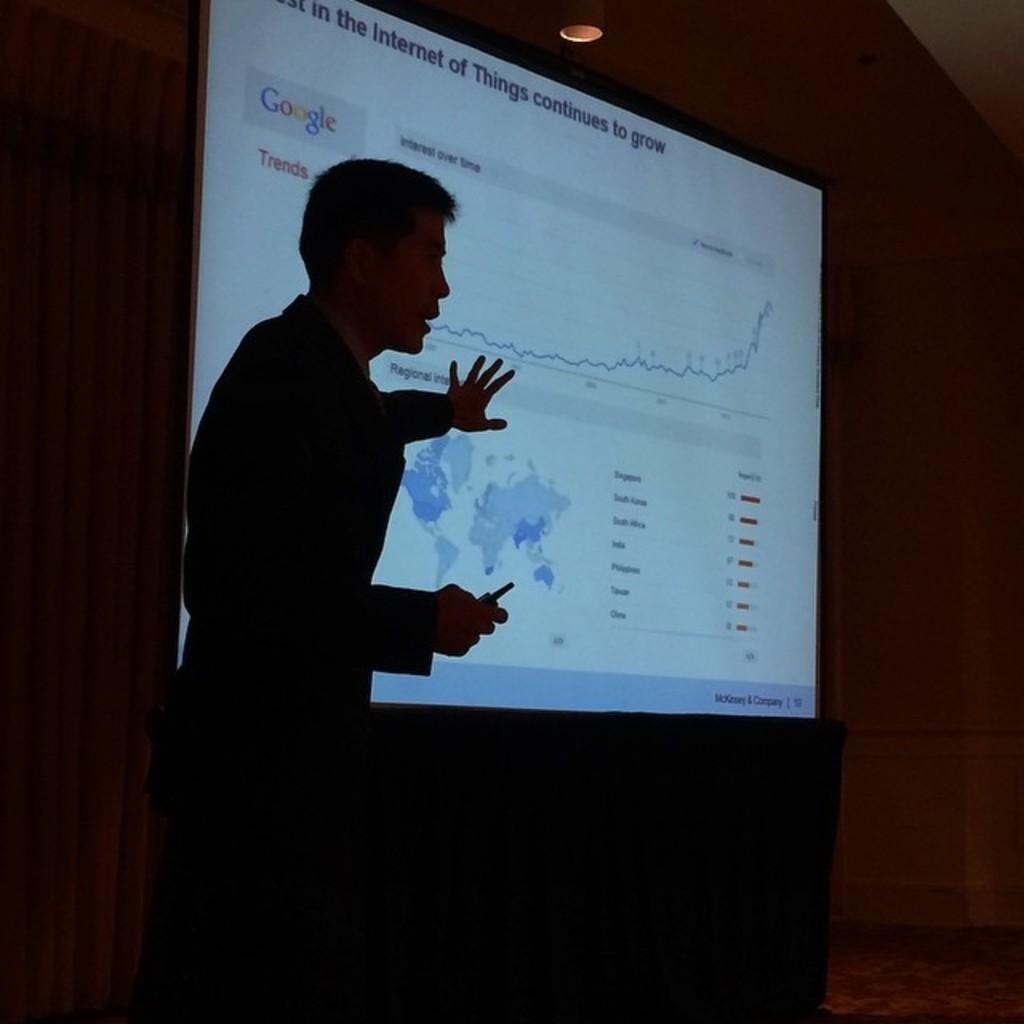What is the person in the image doing? The person is standing in the image and holding an object. What can be seen in the image besides the person? There is a projector in the image, which displays some text and a map. What is the background of the image? The background of the image appears to be a wall. What type of muscle is being flexed by the person in the image? There is no indication in the image that the person is flexing any muscles, so it cannot be determined from the picture. 